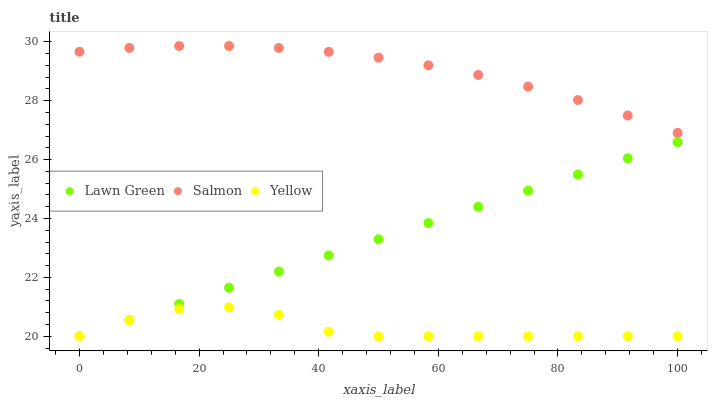Does Yellow have the minimum area under the curve?
Answer yes or no. Yes. Does Salmon have the maximum area under the curve?
Answer yes or no. Yes. Does Salmon have the minimum area under the curve?
Answer yes or no. No. Does Yellow have the maximum area under the curve?
Answer yes or no. No. Is Lawn Green the smoothest?
Answer yes or no. Yes. Is Yellow the roughest?
Answer yes or no. Yes. Is Salmon the smoothest?
Answer yes or no. No. Is Salmon the roughest?
Answer yes or no. No. Does Lawn Green have the lowest value?
Answer yes or no. Yes. Does Salmon have the lowest value?
Answer yes or no. No. Does Salmon have the highest value?
Answer yes or no. Yes. Does Yellow have the highest value?
Answer yes or no. No. Is Lawn Green less than Salmon?
Answer yes or no. Yes. Is Salmon greater than Yellow?
Answer yes or no. Yes. Does Yellow intersect Lawn Green?
Answer yes or no. Yes. Is Yellow less than Lawn Green?
Answer yes or no. No. Is Yellow greater than Lawn Green?
Answer yes or no. No. Does Lawn Green intersect Salmon?
Answer yes or no. No. 